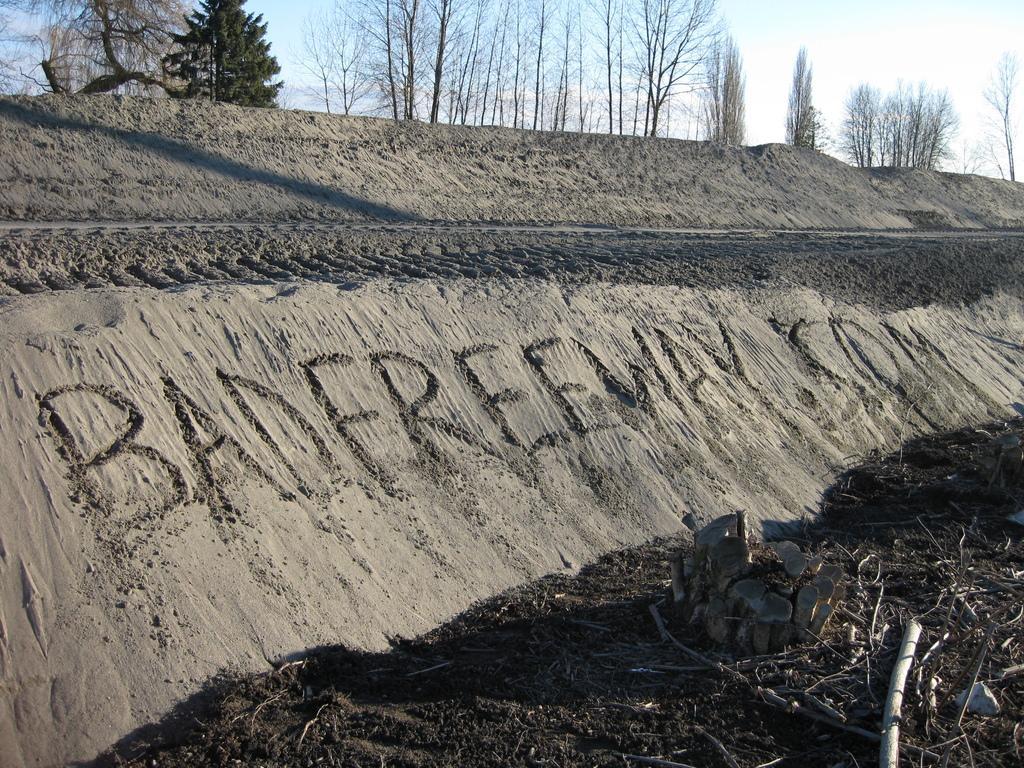Can you describe this image briefly? In this picture there are trees at the top side of the image and there is mud at the bottom side of the image. 